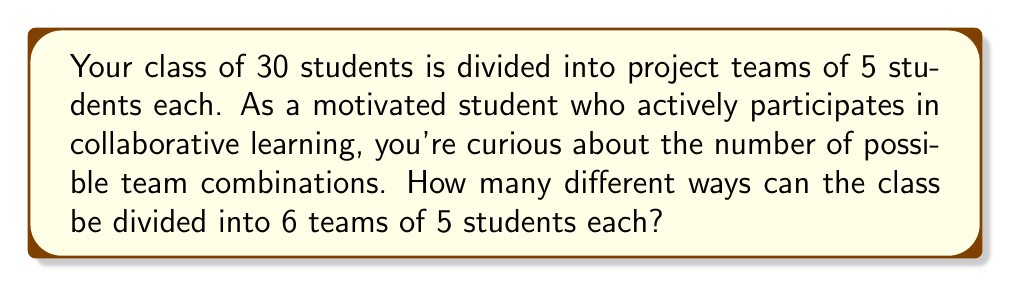What is the answer to this math problem? Let's approach this step-by-step:

1) This is a combination problem where order doesn't matter within each team or among the teams.

2) We can use the concept of multinomial coefficients to solve this.

3) The formula for multinomial coefficients is:

   $$\binom{n}{n_1,n_2,...,n_k} = \frac{n!}{n_1!n_2!...n_k!}$$

   where $n$ is the total number of elements, and $n_1, n_2, ..., n_k$ are the sizes of each group.

4) In our case:
   $n = 30$ (total students)
   $n_1 = n_2 = ... = n_6 = 5$ (6 teams of 5 students each)

5) Plugging into the formula:

   $$\binom{30}{5,5,5,5,5,5} = \frac{30!}{(5!)^6}$$

6) Calculate:
   $30! = 2.65252859812191058636308480000000 \times 10^{32}$
   $(5!)^6 = (120)^6 = 2,985,984,000,000$

7) Divide:
   $$\frac{30!}{(5!)^6} = 8,881,236,634,900,735,303,501$$

8) However, this counts arrangements where the order of the teams matters. Since the order of teams doesn't matter, we need to divide by 6! (the number of ways to arrange 6 teams).

9) Final calculation:
   $$\frac{8,881,236,634,900,735,303,501}{6!} = 12,335,328,661,529,632,922$$
Answer: 12,335,328,661,529,632,922 